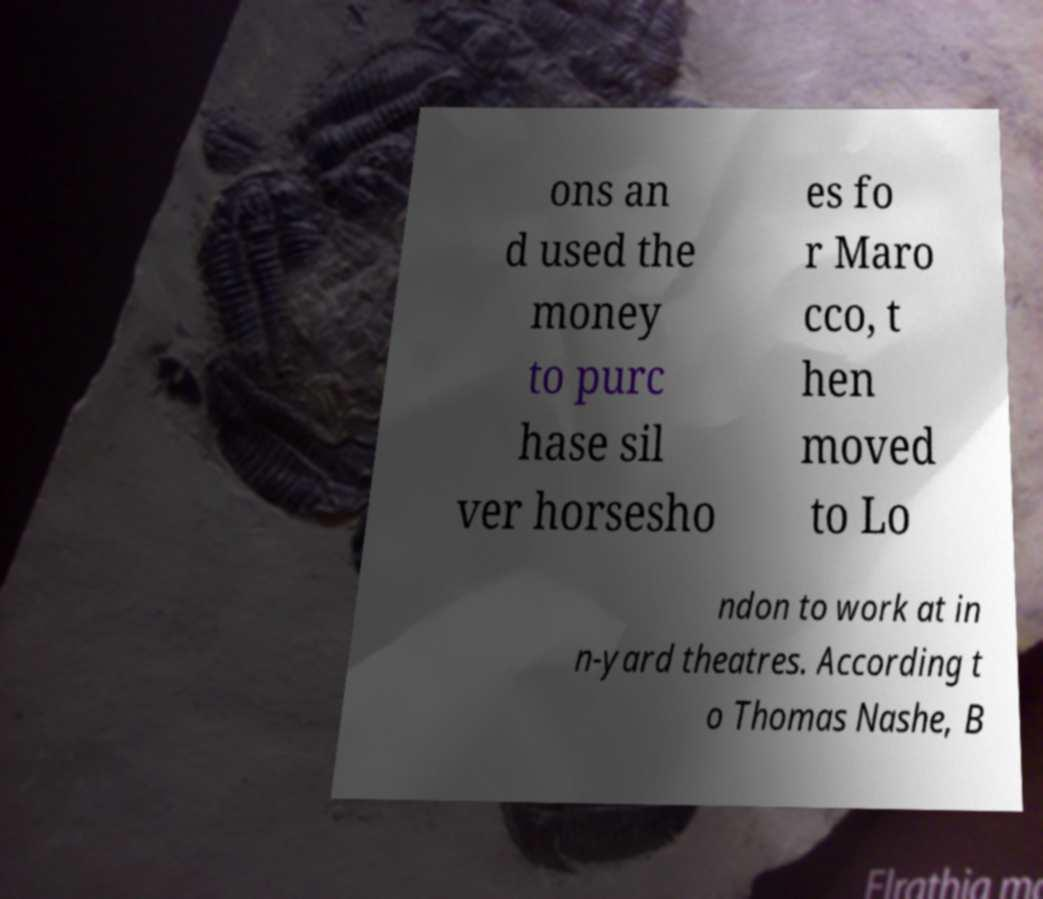There's text embedded in this image that I need extracted. Can you transcribe it verbatim? ons an d used the money to purc hase sil ver horsesho es fo r Maro cco, t hen moved to Lo ndon to work at in n-yard theatres. According t o Thomas Nashe, B 